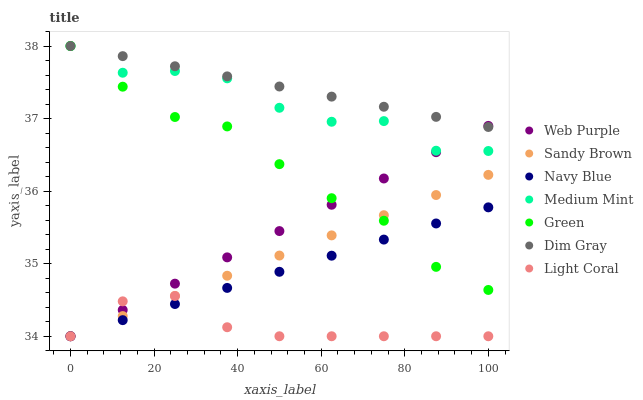Does Light Coral have the minimum area under the curve?
Answer yes or no. Yes. Does Dim Gray have the maximum area under the curve?
Answer yes or no. Yes. Does Navy Blue have the minimum area under the curve?
Answer yes or no. No. Does Navy Blue have the maximum area under the curve?
Answer yes or no. No. Is Navy Blue the smoothest?
Answer yes or no. Yes. Is Medium Mint the roughest?
Answer yes or no. Yes. Is Dim Gray the smoothest?
Answer yes or no. No. Is Dim Gray the roughest?
Answer yes or no. No. Does Navy Blue have the lowest value?
Answer yes or no. Yes. Does Dim Gray have the lowest value?
Answer yes or no. No. Does Green have the highest value?
Answer yes or no. Yes. Does Navy Blue have the highest value?
Answer yes or no. No. Is Light Coral less than Dim Gray?
Answer yes or no. Yes. Is Medium Mint greater than Sandy Brown?
Answer yes or no. Yes. Does Dim Gray intersect Green?
Answer yes or no. Yes. Is Dim Gray less than Green?
Answer yes or no. No. Is Dim Gray greater than Green?
Answer yes or no. No. Does Light Coral intersect Dim Gray?
Answer yes or no. No. 